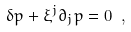<formula> <loc_0><loc_0><loc_500><loc_500>\delta p + \xi ^ { j } \partial _ { j } p = 0 \ ,</formula> 